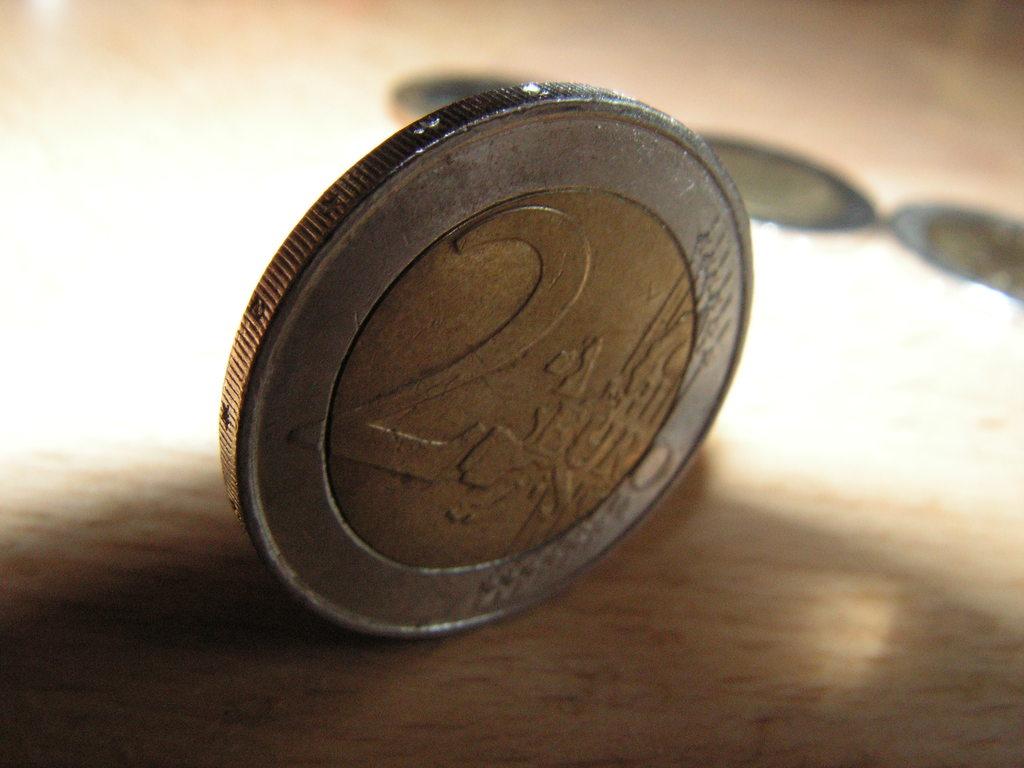What number is on the coin?
Make the answer very short. 2. 